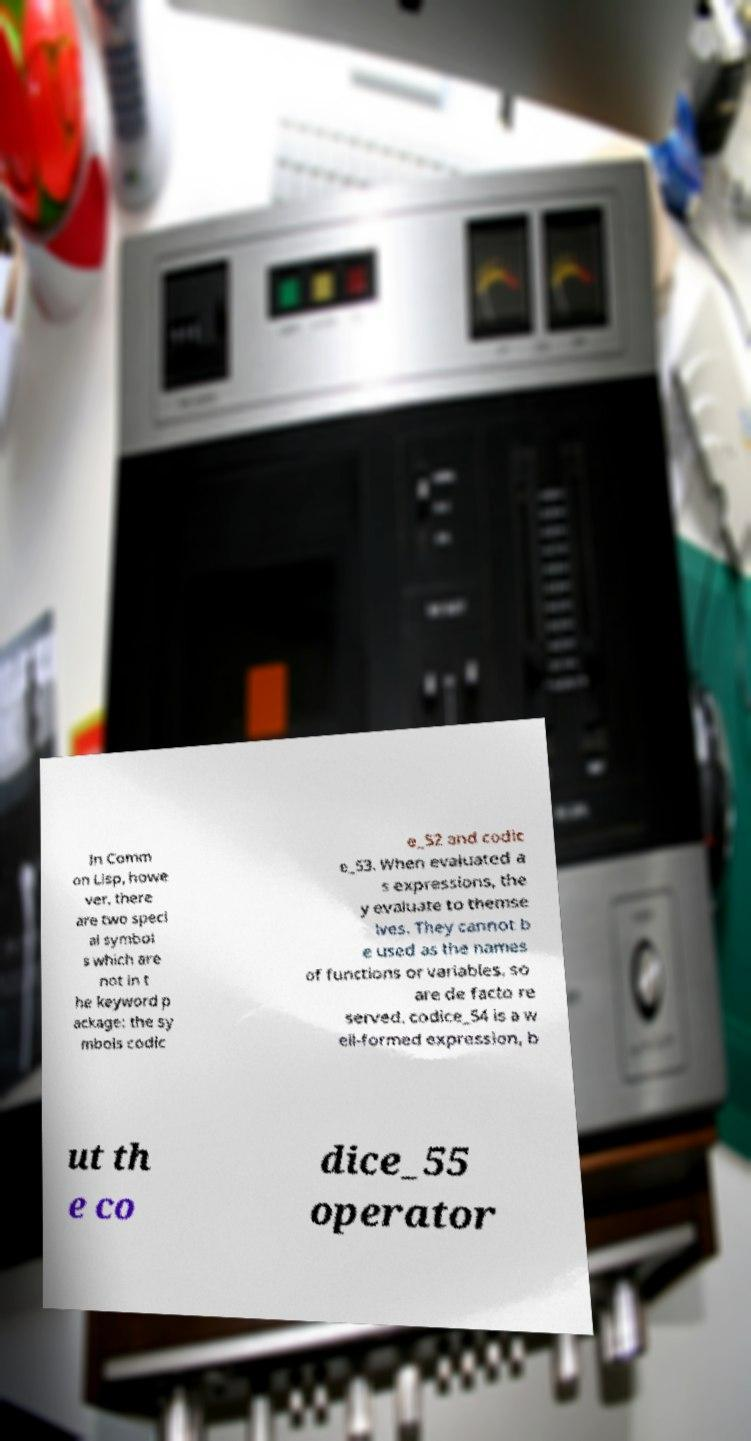For documentation purposes, I need the text within this image transcribed. Could you provide that? In Comm on Lisp, howe ver, there are two speci al symbol s which are not in t he keyword p ackage: the sy mbols codic e_52 and codic e_53. When evaluated a s expressions, the y evaluate to themse lves. They cannot b e used as the names of functions or variables, so are de facto re served. codice_54 is a w ell-formed expression, b ut th e co dice_55 operator 